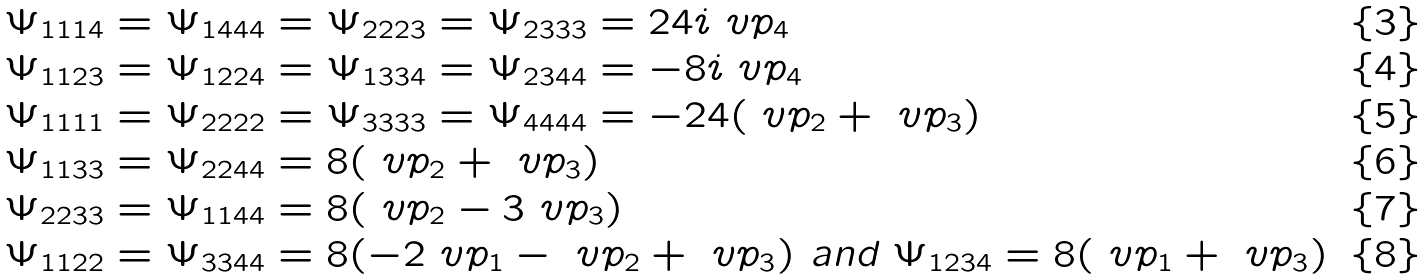<formula> <loc_0><loc_0><loc_500><loc_500>& \Psi _ { 1 1 1 4 } = \Psi _ { 1 4 4 4 } = \Psi _ { 2 2 2 3 } = \Psi _ { 2 3 3 3 } = 2 4 i \ v p _ { 4 } \\ & \Psi _ { 1 1 2 3 } = \Psi _ { 1 2 2 4 } = \Psi _ { 1 3 3 4 } = \Psi _ { 2 3 4 4 } = - 8 i \ v p _ { 4 } \\ & \Psi _ { 1 1 1 1 } = \Psi _ { 2 2 2 2 } = \Psi _ { 3 3 3 3 } = \Psi _ { 4 4 4 4 } = - 2 4 ( \ v p _ { 2 } + \ v p _ { 3 } ) \\ & \Psi _ { 1 1 3 3 } = \Psi _ { 2 2 4 4 } = 8 ( \ v p _ { 2 } + \ v p _ { 3 } ) \\ & \Psi _ { 2 2 3 3 } = \Psi _ { 1 1 4 4 } = 8 ( \ v p _ { 2 } - 3 \ v p _ { 3 } ) \\ & \Psi _ { 1 1 2 2 } = \Psi _ { 3 3 4 4 } = 8 ( - 2 \ v p _ { 1 } - \ v p _ { 2 } + \ v p _ { 3 } ) \text { and } \Psi _ { 1 2 3 4 } = 8 ( \ v p _ { 1 } + \ v p _ { 3 } )</formula> 